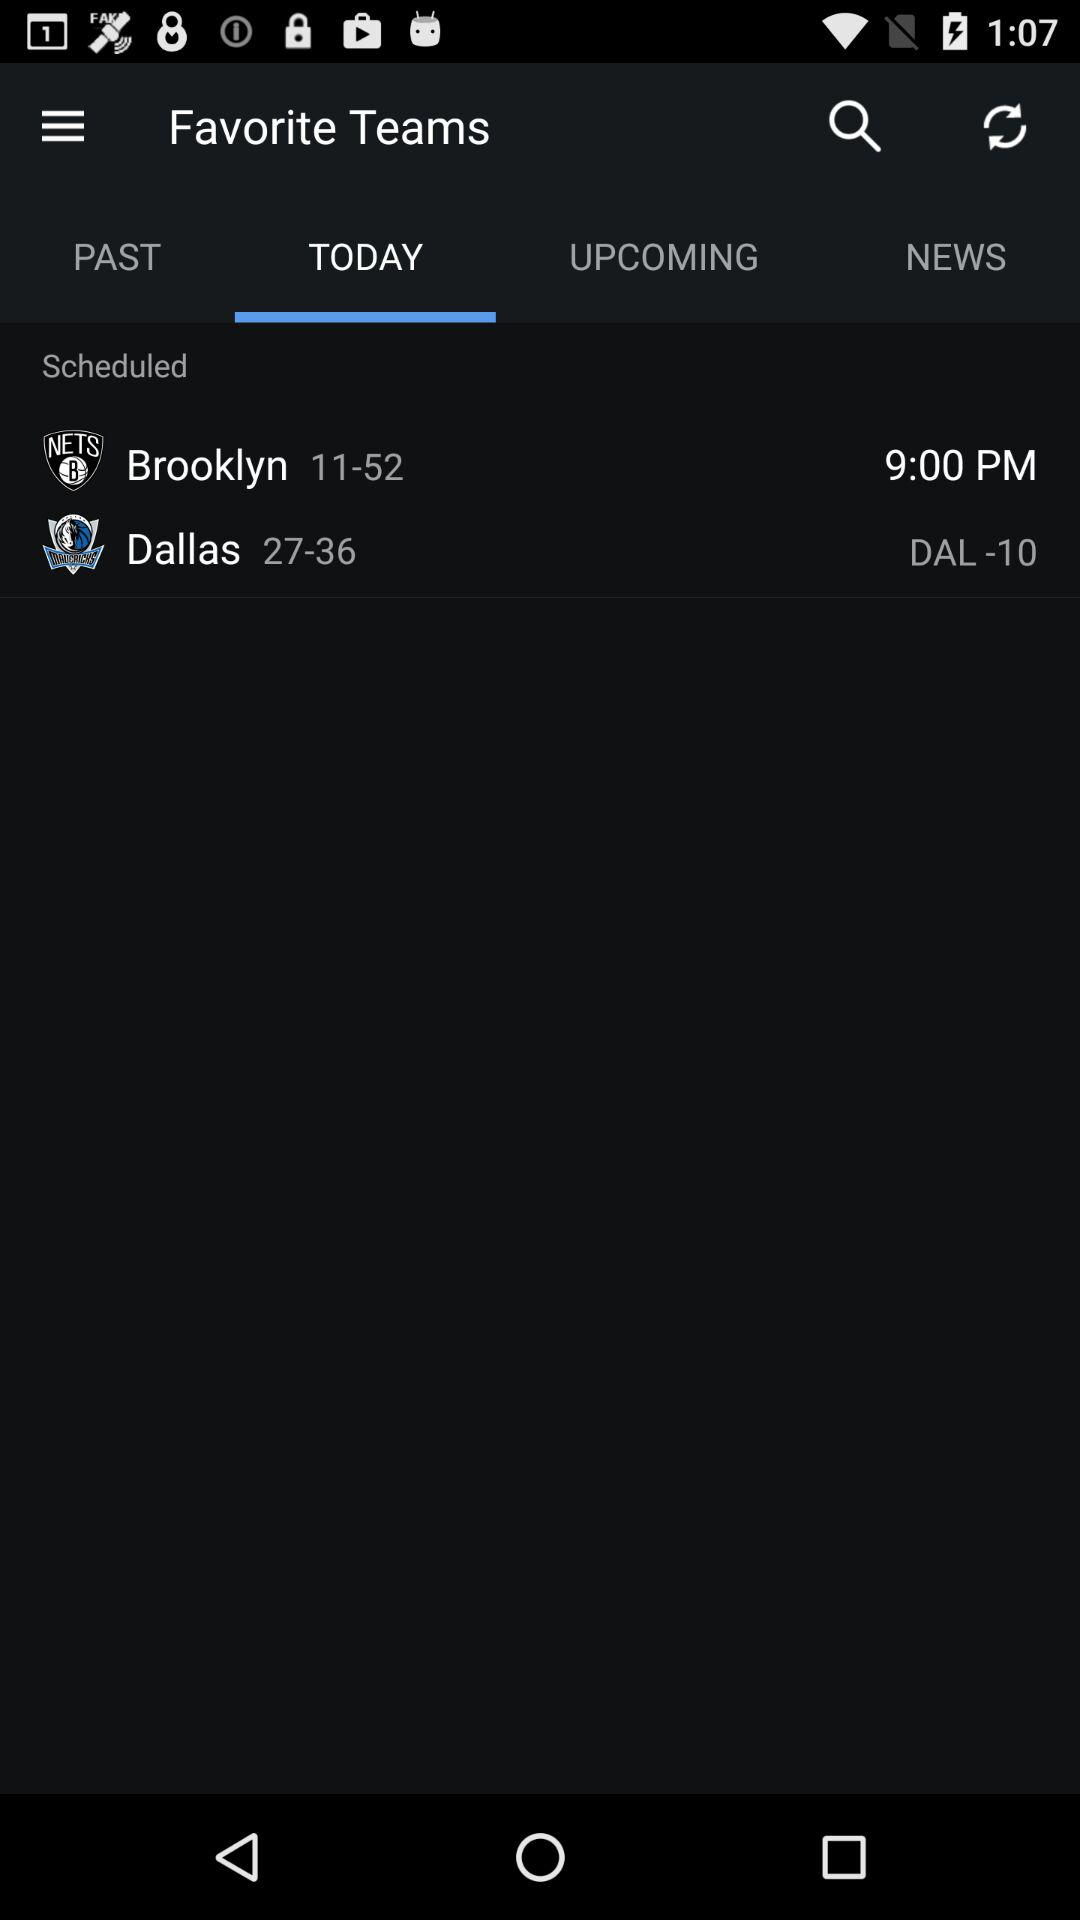Which tab is selected? The selected tab is "TODAY". 